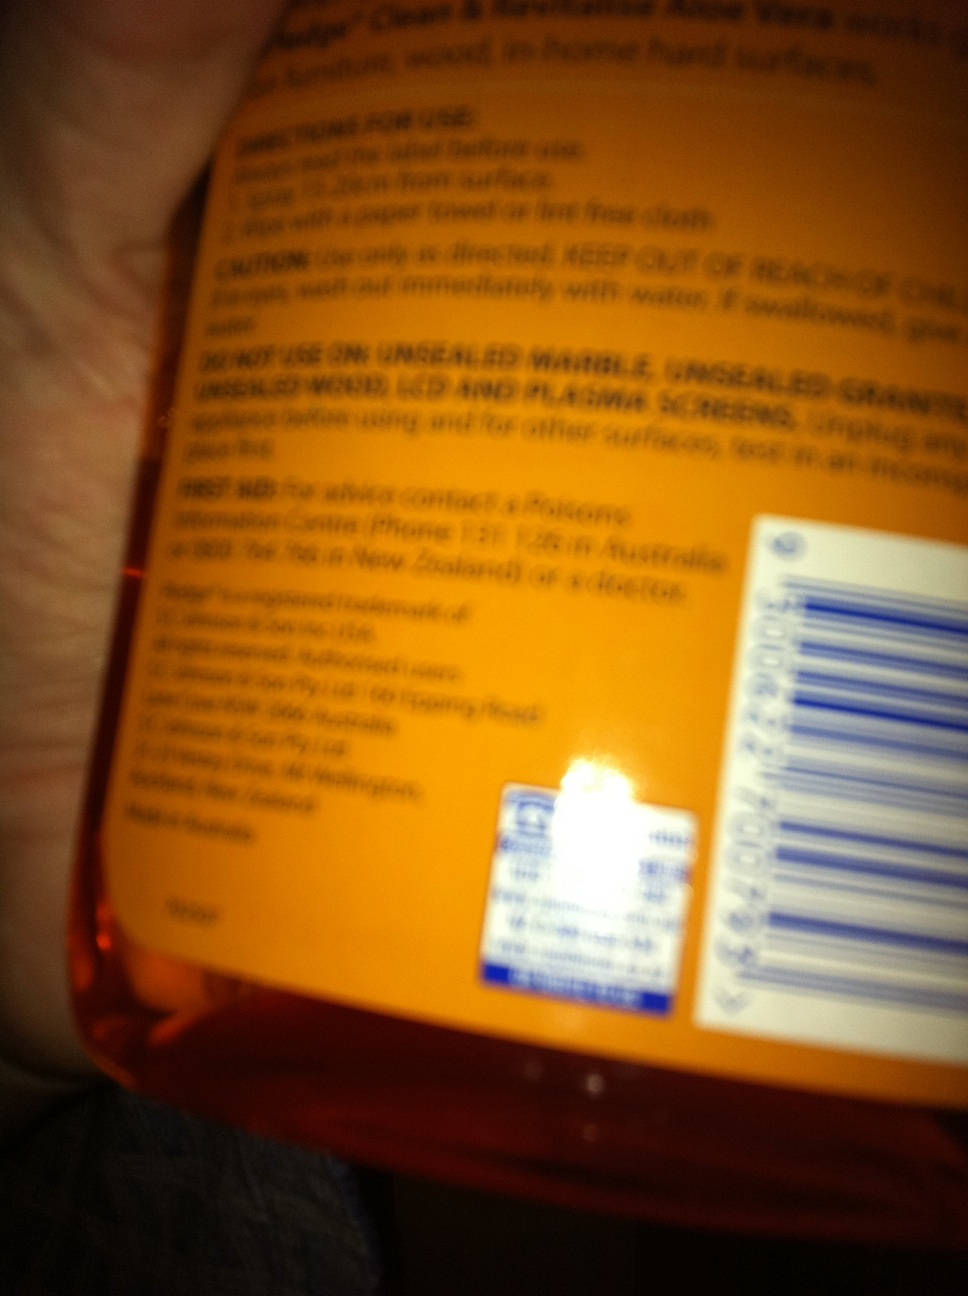Can you tell me more about the usage instructions mentioned on the bottle? The bottle advises that the product should be sprayed directly onto the surface and wiped off with a paper towel or lint-free cloth. It warns against use on unsealed marble, unglazed ceramic, and certain wood and painted surfaces, highlighting its suitability for easier-to-clean surfaces. Is there any safety information provided on the bottle? Yes, there's important safety information on the label. It includes cautions against using the product on unsealed or open surfaces and advises rinsing immediately with water if it's swallowed. This suggests that while the product is effective for cleaning, it must be used carefully to avoid damaging surfaces or health hazards. 